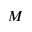Convert formula to latex. <formula><loc_0><loc_0><loc_500><loc_500>M</formula> 